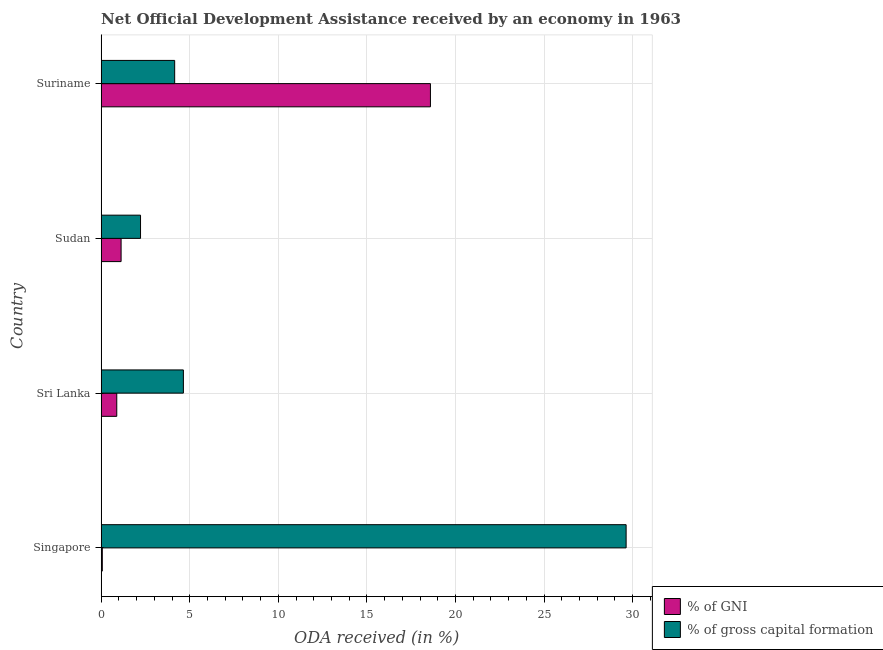Are the number of bars per tick equal to the number of legend labels?
Offer a terse response. Yes. Are the number of bars on each tick of the Y-axis equal?
Your response must be concise. Yes. How many bars are there on the 2nd tick from the top?
Offer a terse response. 2. What is the label of the 2nd group of bars from the top?
Offer a terse response. Sudan. In how many cases, is the number of bars for a given country not equal to the number of legend labels?
Give a very brief answer. 0. What is the oda received as percentage of gross capital formation in Singapore?
Give a very brief answer. 29.63. Across all countries, what is the maximum oda received as percentage of gross capital formation?
Provide a succinct answer. 29.63. Across all countries, what is the minimum oda received as percentage of gross capital formation?
Provide a short and direct response. 2.22. In which country was the oda received as percentage of gni maximum?
Provide a succinct answer. Suriname. In which country was the oda received as percentage of gross capital formation minimum?
Provide a succinct answer. Sudan. What is the total oda received as percentage of gni in the graph?
Provide a succinct answer. 20.66. What is the difference between the oda received as percentage of gross capital formation in Sudan and that in Suriname?
Keep it short and to the point. -1.93. What is the difference between the oda received as percentage of gross capital formation in Sri Lanka and the oda received as percentage of gni in Suriname?
Give a very brief answer. -13.94. What is the average oda received as percentage of gni per country?
Keep it short and to the point. 5.17. What is the difference between the oda received as percentage of gross capital formation and oda received as percentage of gni in Suriname?
Keep it short and to the point. -14.44. In how many countries, is the oda received as percentage of gni greater than 5 %?
Make the answer very short. 1. What is the ratio of the oda received as percentage of gross capital formation in Singapore to that in Sri Lanka?
Your response must be concise. 6.38. Is the oda received as percentage of gross capital formation in Sudan less than that in Suriname?
Offer a terse response. Yes. What is the difference between the highest and the second highest oda received as percentage of gross capital formation?
Your answer should be very brief. 24.99. What is the difference between the highest and the lowest oda received as percentage of gross capital formation?
Provide a succinct answer. 27.41. In how many countries, is the oda received as percentage of gross capital formation greater than the average oda received as percentage of gross capital formation taken over all countries?
Offer a terse response. 1. Is the sum of the oda received as percentage of gross capital formation in Singapore and Suriname greater than the maximum oda received as percentage of gni across all countries?
Offer a terse response. Yes. What does the 2nd bar from the top in Sudan represents?
Keep it short and to the point. % of GNI. What does the 2nd bar from the bottom in Sri Lanka represents?
Provide a short and direct response. % of gross capital formation. How many bars are there?
Keep it short and to the point. 8. Does the graph contain any zero values?
Your answer should be very brief. No. Does the graph contain grids?
Offer a very short reply. Yes. How many legend labels are there?
Make the answer very short. 2. How are the legend labels stacked?
Ensure brevity in your answer.  Vertical. What is the title of the graph?
Offer a very short reply. Net Official Development Assistance received by an economy in 1963. What is the label or title of the X-axis?
Make the answer very short. ODA received (in %). What is the ODA received (in %) in % of GNI in Singapore?
Offer a very short reply. 0.07. What is the ODA received (in %) of % of gross capital formation in Singapore?
Offer a terse response. 29.63. What is the ODA received (in %) in % of GNI in Sri Lanka?
Your response must be concise. 0.88. What is the ODA received (in %) of % of gross capital formation in Sri Lanka?
Offer a very short reply. 4.64. What is the ODA received (in %) of % of GNI in Sudan?
Provide a short and direct response. 1.13. What is the ODA received (in %) of % of gross capital formation in Sudan?
Your answer should be very brief. 2.22. What is the ODA received (in %) in % of GNI in Suriname?
Provide a short and direct response. 18.58. What is the ODA received (in %) in % of gross capital formation in Suriname?
Offer a very short reply. 4.15. Across all countries, what is the maximum ODA received (in %) in % of GNI?
Ensure brevity in your answer.  18.58. Across all countries, what is the maximum ODA received (in %) of % of gross capital formation?
Your answer should be very brief. 29.63. Across all countries, what is the minimum ODA received (in %) in % of GNI?
Your response must be concise. 0.07. Across all countries, what is the minimum ODA received (in %) in % of gross capital formation?
Your response must be concise. 2.22. What is the total ODA received (in %) of % of GNI in the graph?
Make the answer very short. 20.66. What is the total ODA received (in %) of % of gross capital formation in the graph?
Your answer should be compact. 40.64. What is the difference between the ODA received (in %) in % of GNI in Singapore and that in Sri Lanka?
Keep it short and to the point. -0.82. What is the difference between the ODA received (in %) of % of gross capital formation in Singapore and that in Sri Lanka?
Keep it short and to the point. 24.99. What is the difference between the ODA received (in %) of % of GNI in Singapore and that in Sudan?
Ensure brevity in your answer.  -1.06. What is the difference between the ODA received (in %) of % of gross capital formation in Singapore and that in Sudan?
Make the answer very short. 27.41. What is the difference between the ODA received (in %) of % of GNI in Singapore and that in Suriname?
Provide a succinct answer. -18.52. What is the difference between the ODA received (in %) in % of gross capital formation in Singapore and that in Suriname?
Provide a succinct answer. 25.48. What is the difference between the ODA received (in %) in % of GNI in Sri Lanka and that in Sudan?
Offer a terse response. -0.24. What is the difference between the ODA received (in %) in % of gross capital formation in Sri Lanka and that in Sudan?
Offer a very short reply. 2.42. What is the difference between the ODA received (in %) of % of GNI in Sri Lanka and that in Suriname?
Offer a very short reply. -17.7. What is the difference between the ODA received (in %) in % of gross capital formation in Sri Lanka and that in Suriname?
Keep it short and to the point. 0.49. What is the difference between the ODA received (in %) in % of GNI in Sudan and that in Suriname?
Give a very brief answer. -17.46. What is the difference between the ODA received (in %) of % of gross capital formation in Sudan and that in Suriname?
Make the answer very short. -1.93. What is the difference between the ODA received (in %) in % of GNI in Singapore and the ODA received (in %) in % of gross capital formation in Sri Lanka?
Ensure brevity in your answer.  -4.58. What is the difference between the ODA received (in %) in % of GNI in Singapore and the ODA received (in %) in % of gross capital formation in Sudan?
Offer a very short reply. -2.16. What is the difference between the ODA received (in %) of % of GNI in Singapore and the ODA received (in %) of % of gross capital formation in Suriname?
Offer a very short reply. -4.08. What is the difference between the ODA received (in %) in % of GNI in Sri Lanka and the ODA received (in %) in % of gross capital formation in Sudan?
Provide a short and direct response. -1.34. What is the difference between the ODA received (in %) of % of GNI in Sri Lanka and the ODA received (in %) of % of gross capital formation in Suriname?
Give a very brief answer. -3.27. What is the difference between the ODA received (in %) of % of GNI in Sudan and the ODA received (in %) of % of gross capital formation in Suriname?
Offer a terse response. -3.02. What is the average ODA received (in %) in % of GNI per country?
Provide a short and direct response. 5.16. What is the average ODA received (in %) of % of gross capital formation per country?
Provide a succinct answer. 10.16. What is the difference between the ODA received (in %) in % of GNI and ODA received (in %) in % of gross capital formation in Singapore?
Provide a short and direct response. -29.56. What is the difference between the ODA received (in %) of % of GNI and ODA received (in %) of % of gross capital formation in Sri Lanka?
Give a very brief answer. -3.76. What is the difference between the ODA received (in %) of % of GNI and ODA received (in %) of % of gross capital formation in Sudan?
Your answer should be compact. -1.1. What is the difference between the ODA received (in %) of % of GNI and ODA received (in %) of % of gross capital formation in Suriname?
Your response must be concise. 14.44. What is the ratio of the ODA received (in %) in % of GNI in Singapore to that in Sri Lanka?
Keep it short and to the point. 0.07. What is the ratio of the ODA received (in %) in % of gross capital formation in Singapore to that in Sri Lanka?
Provide a succinct answer. 6.38. What is the ratio of the ODA received (in %) of % of GNI in Singapore to that in Sudan?
Your answer should be very brief. 0.06. What is the ratio of the ODA received (in %) in % of gross capital formation in Singapore to that in Sudan?
Offer a very short reply. 13.33. What is the ratio of the ODA received (in %) in % of GNI in Singapore to that in Suriname?
Your response must be concise. 0. What is the ratio of the ODA received (in %) in % of gross capital formation in Singapore to that in Suriname?
Provide a short and direct response. 7.14. What is the ratio of the ODA received (in %) in % of GNI in Sri Lanka to that in Sudan?
Ensure brevity in your answer.  0.78. What is the ratio of the ODA received (in %) of % of gross capital formation in Sri Lanka to that in Sudan?
Provide a short and direct response. 2.09. What is the ratio of the ODA received (in %) of % of GNI in Sri Lanka to that in Suriname?
Your answer should be compact. 0.05. What is the ratio of the ODA received (in %) of % of gross capital formation in Sri Lanka to that in Suriname?
Provide a short and direct response. 1.12. What is the ratio of the ODA received (in %) in % of GNI in Sudan to that in Suriname?
Your answer should be very brief. 0.06. What is the ratio of the ODA received (in %) of % of gross capital formation in Sudan to that in Suriname?
Your answer should be very brief. 0.54. What is the difference between the highest and the second highest ODA received (in %) in % of GNI?
Offer a terse response. 17.46. What is the difference between the highest and the second highest ODA received (in %) of % of gross capital formation?
Give a very brief answer. 24.99. What is the difference between the highest and the lowest ODA received (in %) of % of GNI?
Ensure brevity in your answer.  18.52. What is the difference between the highest and the lowest ODA received (in %) in % of gross capital formation?
Provide a succinct answer. 27.41. 